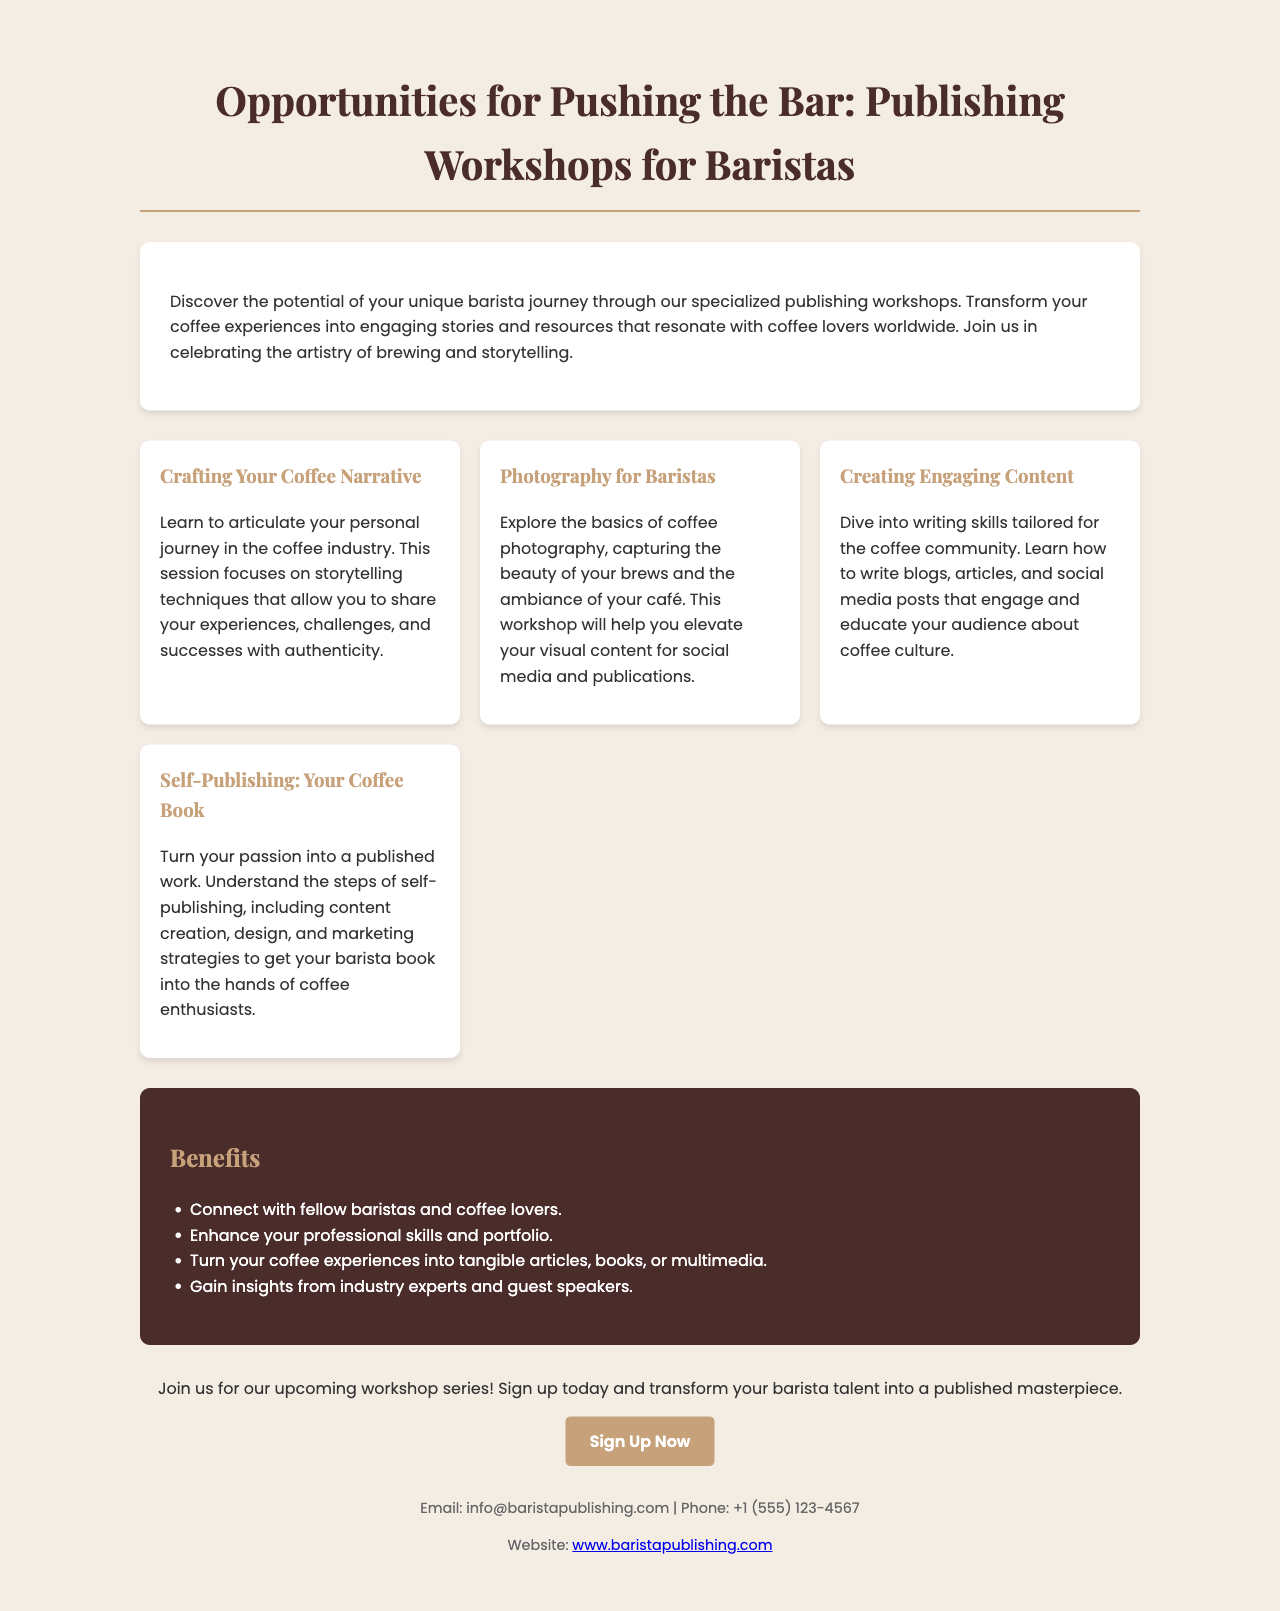What is the title of the brochure? The title of the brochure is prominently displayed at the top, stating the purpose of the workshops for baristas.
Answer: Opportunities for Pushing the Bar: Publishing Workshops for Baristas How many workshops are listed in the brochure? The number of workshops can be counted from the section detailing the workshops offered for baristas.
Answer: Four What is the first workshop mentioned? The first workshop is listed in the workshops section and focuses on barista storytelling techniques.
Answer: Crafting Your Coffee Narrative What is one benefit of participating in these workshops? Benefits are outlined in a bullet point format; any single benefit can be selected as an answer.
Answer: Connect with fellow baristas and coffee lovers What is the contact email provided in the brochure? The specific email address for inquiries appears in the contact information section of the brochure.
Answer: info@baristapublishing.com Which workshop teaches photography skills? This workshop is specifically noted for its focus on coffee photography within the workshops section.
Answer: Photography for Baristas What is the purpose of the “Sign Up Now” button? The button's intention is described in the call-to-action section, indicating it is for registration purposes.
Answer: To sign up for the workshops What type of content will you learn to create in the “Creating Engaging Content” workshop? This workshop addresses the types of writing that will be taught, as described in its details.
Answer: Blogs, articles, and social media posts What is the phone number listed for contact? The phone number can be found in the contact section and is a method for reaching out.
Answer: +1 (555) 123-4567 